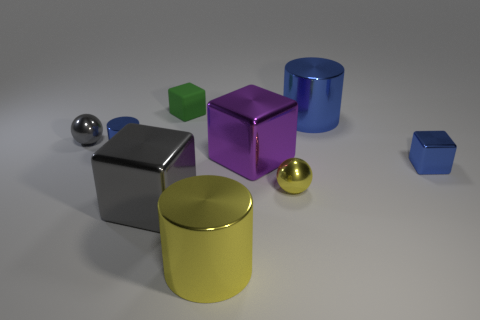Are any tiny yellow things visible?
Your response must be concise. Yes. Are there the same number of green rubber cubes that are right of the small yellow metallic thing and matte things?
Keep it short and to the point. No. How many other things are there of the same shape as the big gray thing?
Give a very brief answer. 3. The big blue thing is what shape?
Your answer should be very brief. Cylinder. Is the material of the tiny blue cube the same as the purple cube?
Keep it short and to the point. Yes. Is the number of large blue metal things to the left of the yellow cylinder the same as the number of tiny balls on the right side of the small blue metal block?
Provide a short and direct response. Yes. Are there any big metal cylinders left of the tiny metallic ball on the right side of the blue metallic cylinder that is left of the green rubber object?
Give a very brief answer. Yes. Do the rubber object and the gray shiny block have the same size?
Offer a very short reply. No. There is a small rubber cube that is behind the shiny ball that is in front of the metallic ball that is behind the tiny yellow metal ball; what color is it?
Offer a terse response. Green. What number of rubber blocks are the same color as the matte thing?
Offer a very short reply. 0. 